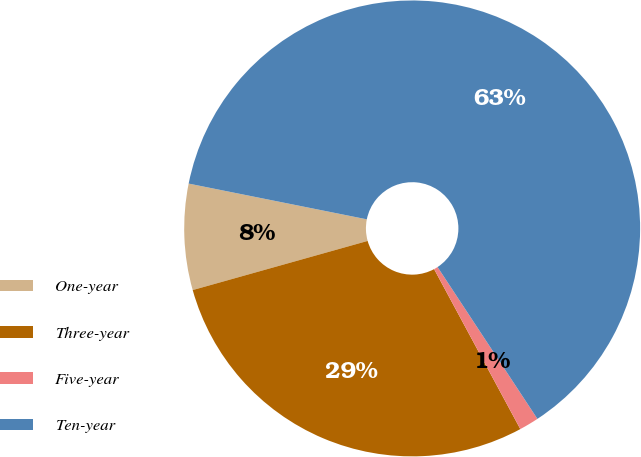Convert chart. <chart><loc_0><loc_0><loc_500><loc_500><pie_chart><fcel>One-year<fcel>Three-year<fcel>Five-year<fcel>Ten-year<nl><fcel>7.51%<fcel>28.51%<fcel>1.39%<fcel>62.59%<nl></chart> 